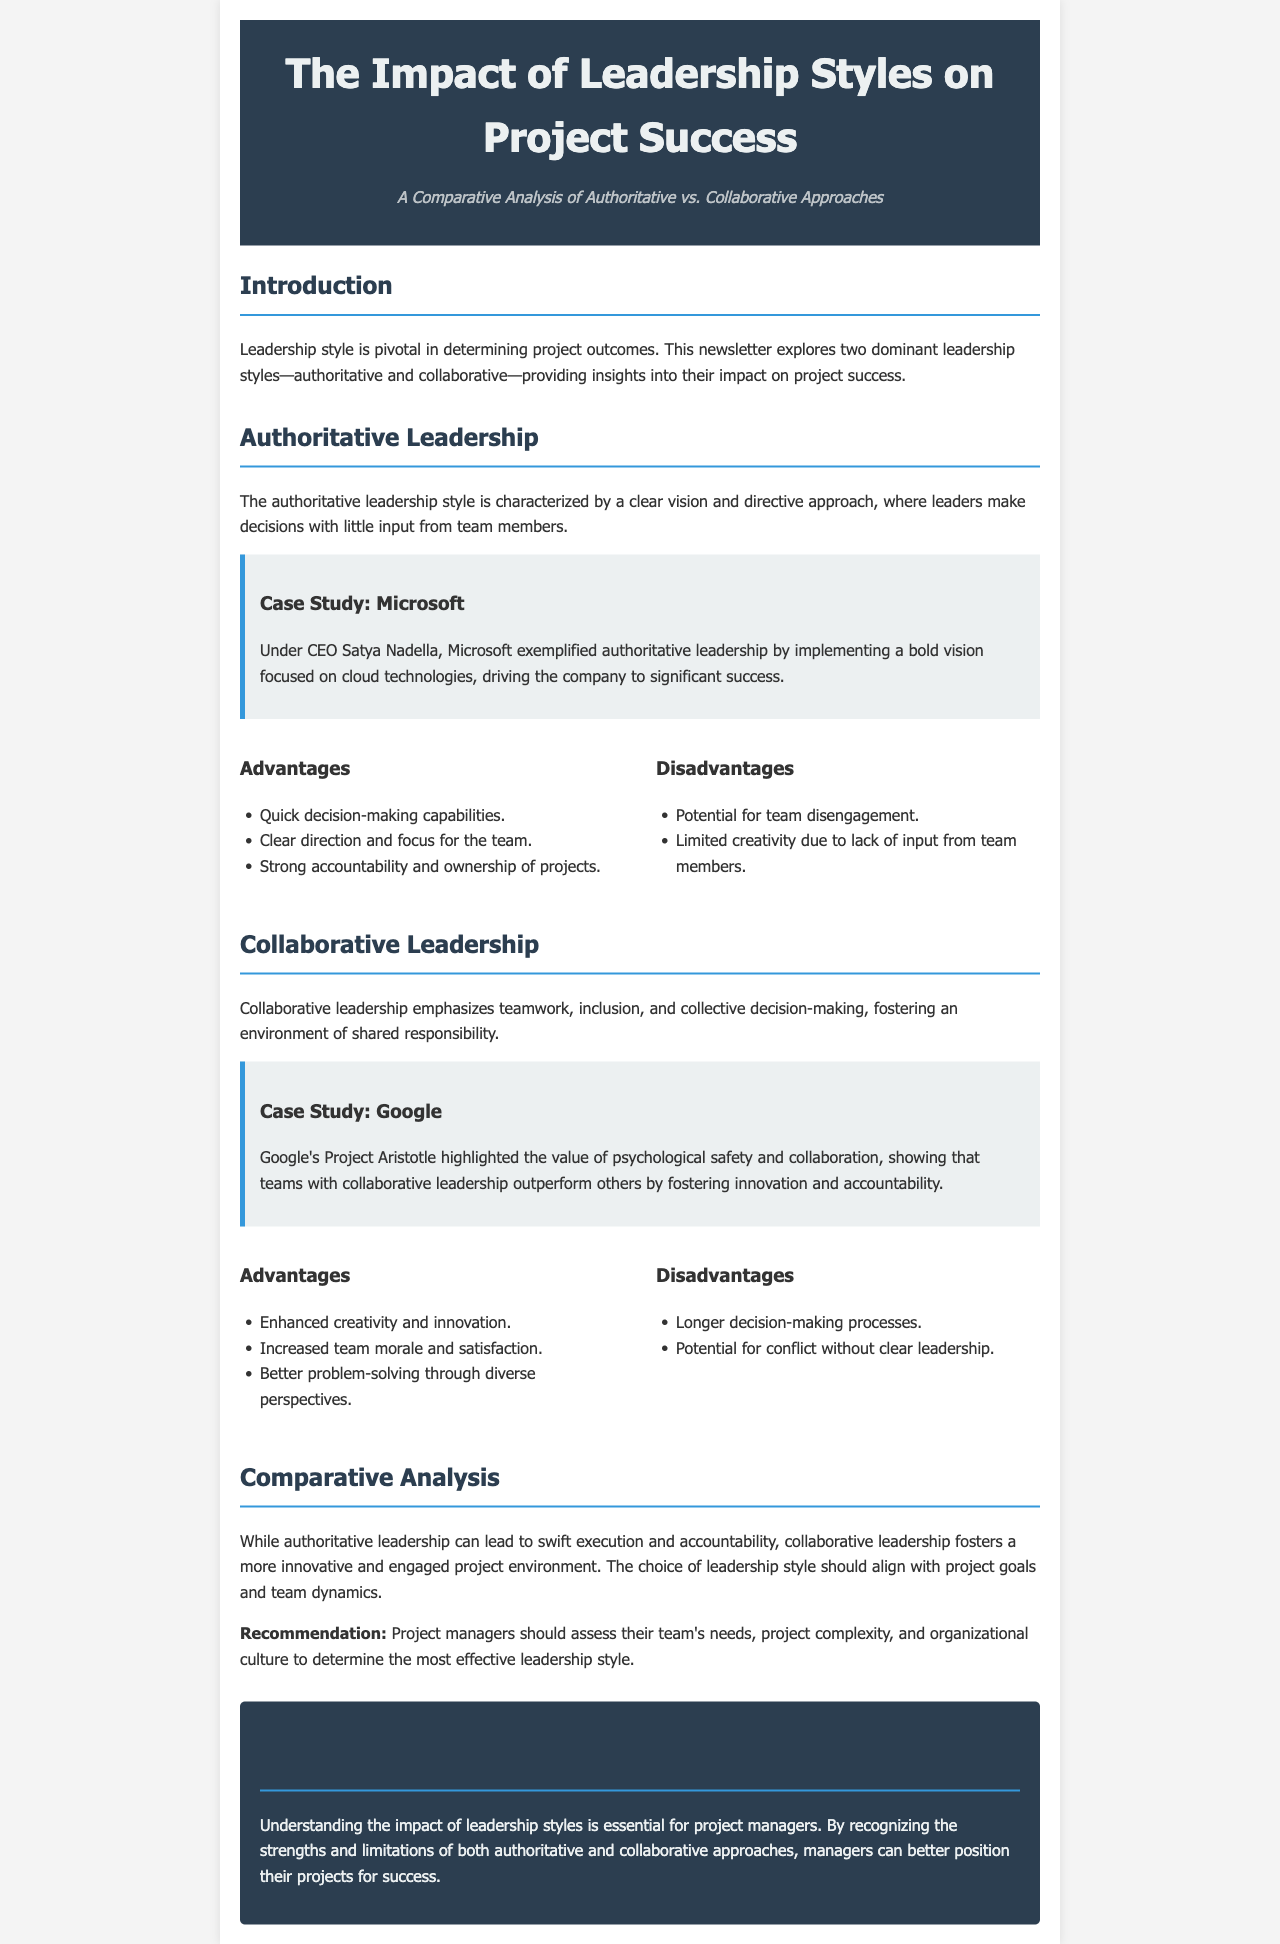What are the two leadership styles compared in the newsletter? The newsletter explicitly states that it compares authoritative and collaborative leadership styles.
Answer: authoritative and collaborative Who is mentioned as the CEO in the case study of Microsoft? The document identifies Satya Nadella as the CEO of Microsoft under the authoritative leadership case study.
Answer: Satya Nadella What major focus did Microsoft's authoritative leadership implement? The document highlights that Microsoft's focus under authoritative leadership was on cloud technologies.
Answer: cloud technologies What was the result of Google's Project Aristotle? The newsletter states that Google’s Project Aristotle demonstrated that teams with collaborative leadership outperform others.
Answer: outperform others What is a disadvantage of collaborative leadership mentioned in the document? The newsletter lists longer decision-making processes as a disadvantage of collaborative leadership.
Answer: longer decision-making processes What should project managers assess to determine the most effective leadership style? The document recommends that project managers should assess their team's needs, project complexity, and organizational culture.
Answer: team’s needs, project complexity, and organizational culture What does authoritative leadership provide for the team? The newsletter states that authoritative leadership provides clear direction and focus for the team.
Answer: clear direction and focus What does the conclusion emphasize about leadership styles? The conclusion stresses the importance of understanding the impact of leadership styles for project managers.
Answer: understanding the impact of leadership styles 